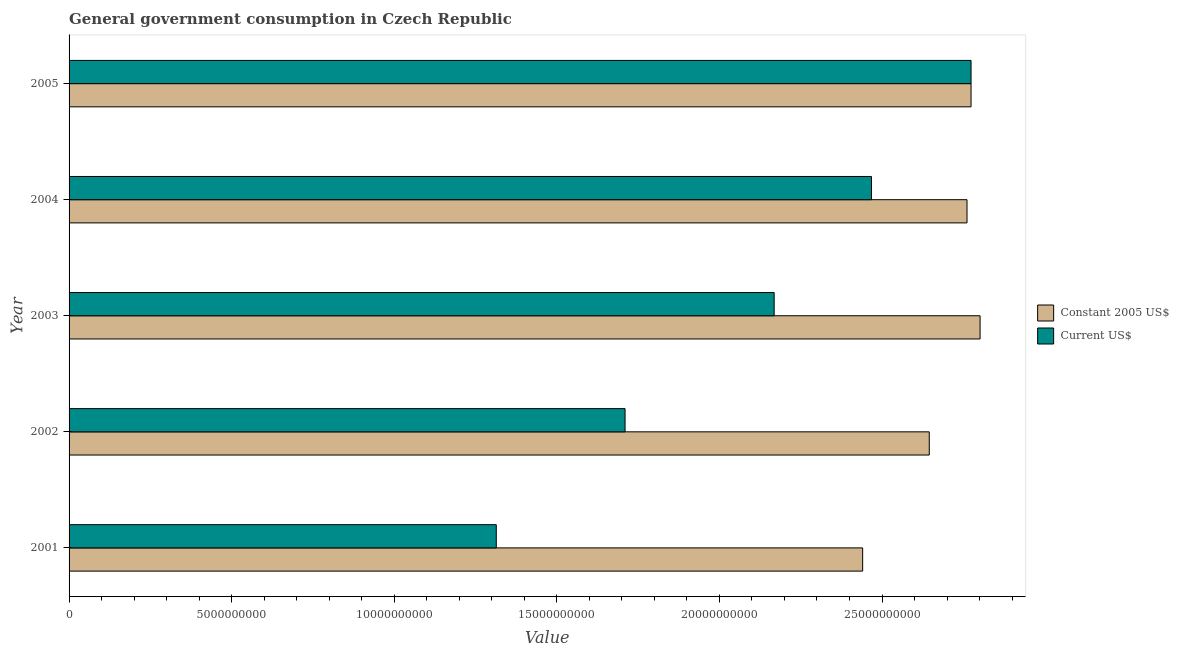How many bars are there on the 3rd tick from the bottom?
Keep it short and to the point. 2. What is the label of the 4th group of bars from the top?
Ensure brevity in your answer.  2002. What is the value consumed in constant 2005 us$ in 2002?
Give a very brief answer. 2.65e+1. Across all years, what is the maximum value consumed in constant 2005 us$?
Make the answer very short. 2.80e+1. Across all years, what is the minimum value consumed in current us$?
Your response must be concise. 1.31e+1. In which year was the value consumed in current us$ maximum?
Your answer should be very brief. 2005. What is the total value consumed in current us$ in the graph?
Offer a very short reply. 1.04e+11. What is the difference between the value consumed in current us$ in 2002 and that in 2003?
Make the answer very short. -4.59e+09. What is the difference between the value consumed in constant 2005 us$ in 2002 and the value consumed in current us$ in 2001?
Your response must be concise. 1.33e+1. What is the average value consumed in current us$ per year?
Offer a terse response. 2.09e+1. In the year 2001, what is the difference between the value consumed in current us$ and value consumed in constant 2005 us$?
Your response must be concise. -1.13e+1. What is the ratio of the value consumed in current us$ in 2001 to that in 2003?
Offer a terse response. 0.61. Is the difference between the value consumed in constant 2005 us$ in 2001 and 2002 greater than the difference between the value consumed in current us$ in 2001 and 2002?
Ensure brevity in your answer.  Yes. What is the difference between the highest and the second highest value consumed in current us$?
Your response must be concise. 3.06e+09. What is the difference between the highest and the lowest value consumed in constant 2005 us$?
Offer a very short reply. 3.61e+09. What does the 1st bar from the top in 2001 represents?
Provide a short and direct response. Current US$. What does the 1st bar from the bottom in 2004 represents?
Keep it short and to the point. Constant 2005 US$. How many bars are there?
Offer a very short reply. 10. Are all the bars in the graph horizontal?
Offer a very short reply. Yes. What is the difference between two consecutive major ticks on the X-axis?
Offer a very short reply. 5.00e+09. Where does the legend appear in the graph?
Give a very brief answer. Center right. How are the legend labels stacked?
Give a very brief answer. Vertical. What is the title of the graph?
Make the answer very short. General government consumption in Czech Republic. Does "Fixed telephone" appear as one of the legend labels in the graph?
Offer a very short reply. No. What is the label or title of the X-axis?
Give a very brief answer. Value. What is the label or title of the Y-axis?
Your answer should be compact. Year. What is the Value in Constant 2005 US$ in 2001?
Ensure brevity in your answer.  2.44e+1. What is the Value in Current US$ in 2001?
Ensure brevity in your answer.  1.31e+1. What is the Value of Constant 2005 US$ in 2002?
Provide a succinct answer. 2.65e+1. What is the Value of Current US$ in 2002?
Keep it short and to the point. 1.71e+1. What is the Value in Constant 2005 US$ in 2003?
Offer a very short reply. 2.80e+1. What is the Value of Current US$ in 2003?
Your answer should be very brief. 2.17e+1. What is the Value in Constant 2005 US$ in 2004?
Provide a short and direct response. 2.76e+1. What is the Value of Current US$ in 2004?
Provide a short and direct response. 2.47e+1. What is the Value of Constant 2005 US$ in 2005?
Your response must be concise. 2.77e+1. What is the Value of Current US$ in 2005?
Your answer should be very brief. 2.77e+1. Across all years, what is the maximum Value of Constant 2005 US$?
Offer a very short reply. 2.80e+1. Across all years, what is the maximum Value of Current US$?
Offer a terse response. 2.77e+1. Across all years, what is the minimum Value in Constant 2005 US$?
Your response must be concise. 2.44e+1. Across all years, what is the minimum Value of Current US$?
Ensure brevity in your answer.  1.31e+1. What is the total Value of Constant 2005 US$ in the graph?
Your answer should be compact. 1.34e+11. What is the total Value in Current US$ in the graph?
Your answer should be very brief. 1.04e+11. What is the difference between the Value of Constant 2005 US$ in 2001 and that in 2002?
Offer a terse response. -2.05e+09. What is the difference between the Value of Current US$ in 2001 and that in 2002?
Keep it short and to the point. -3.96e+09. What is the difference between the Value in Constant 2005 US$ in 2001 and that in 2003?
Offer a very short reply. -3.61e+09. What is the difference between the Value in Current US$ in 2001 and that in 2003?
Give a very brief answer. -8.55e+09. What is the difference between the Value in Constant 2005 US$ in 2001 and that in 2004?
Offer a terse response. -3.21e+09. What is the difference between the Value of Current US$ in 2001 and that in 2004?
Ensure brevity in your answer.  -1.15e+1. What is the difference between the Value in Constant 2005 US$ in 2001 and that in 2005?
Offer a terse response. -3.33e+09. What is the difference between the Value of Current US$ in 2001 and that in 2005?
Keep it short and to the point. -1.46e+1. What is the difference between the Value of Constant 2005 US$ in 2002 and that in 2003?
Your response must be concise. -1.56e+09. What is the difference between the Value in Current US$ in 2002 and that in 2003?
Offer a terse response. -4.59e+09. What is the difference between the Value of Constant 2005 US$ in 2002 and that in 2004?
Give a very brief answer. -1.16e+09. What is the difference between the Value of Current US$ in 2002 and that in 2004?
Give a very brief answer. -7.58e+09. What is the difference between the Value of Constant 2005 US$ in 2002 and that in 2005?
Your answer should be very brief. -1.28e+09. What is the difference between the Value in Current US$ in 2002 and that in 2005?
Provide a short and direct response. -1.06e+1. What is the difference between the Value of Constant 2005 US$ in 2003 and that in 2004?
Give a very brief answer. 4.02e+08. What is the difference between the Value of Current US$ in 2003 and that in 2004?
Your answer should be compact. -2.99e+09. What is the difference between the Value of Constant 2005 US$ in 2003 and that in 2005?
Offer a very short reply. 2.78e+08. What is the difference between the Value in Current US$ in 2003 and that in 2005?
Your answer should be very brief. -6.05e+09. What is the difference between the Value in Constant 2005 US$ in 2004 and that in 2005?
Ensure brevity in your answer.  -1.24e+08. What is the difference between the Value in Current US$ in 2004 and that in 2005?
Provide a short and direct response. -3.06e+09. What is the difference between the Value of Constant 2005 US$ in 2001 and the Value of Current US$ in 2002?
Ensure brevity in your answer.  7.31e+09. What is the difference between the Value of Constant 2005 US$ in 2001 and the Value of Current US$ in 2003?
Keep it short and to the point. 2.72e+09. What is the difference between the Value of Constant 2005 US$ in 2001 and the Value of Current US$ in 2004?
Give a very brief answer. -2.70e+08. What is the difference between the Value in Constant 2005 US$ in 2001 and the Value in Current US$ in 2005?
Provide a short and direct response. -3.33e+09. What is the difference between the Value in Constant 2005 US$ in 2002 and the Value in Current US$ in 2003?
Offer a terse response. 4.77e+09. What is the difference between the Value of Constant 2005 US$ in 2002 and the Value of Current US$ in 2004?
Provide a short and direct response. 1.78e+09. What is the difference between the Value in Constant 2005 US$ in 2002 and the Value in Current US$ in 2005?
Provide a succinct answer. -1.28e+09. What is the difference between the Value of Constant 2005 US$ in 2003 and the Value of Current US$ in 2004?
Keep it short and to the point. 3.34e+09. What is the difference between the Value of Constant 2005 US$ in 2003 and the Value of Current US$ in 2005?
Provide a succinct answer. 2.78e+08. What is the difference between the Value in Constant 2005 US$ in 2004 and the Value in Current US$ in 2005?
Your answer should be compact. -1.24e+08. What is the average Value of Constant 2005 US$ per year?
Offer a terse response. 2.68e+1. What is the average Value of Current US$ per year?
Provide a succinct answer. 2.09e+1. In the year 2001, what is the difference between the Value of Constant 2005 US$ and Value of Current US$?
Offer a very short reply. 1.13e+1. In the year 2002, what is the difference between the Value of Constant 2005 US$ and Value of Current US$?
Your answer should be very brief. 9.35e+09. In the year 2003, what is the difference between the Value in Constant 2005 US$ and Value in Current US$?
Your response must be concise. 6.33e+09. In the year 2004, what is the difference between the Value of Constant 2005 US$ and Value of Current US$?
Your response must be concise. 2.94e+09. In the year 2005, what is the difference between the Value of Constant 2005 US$ and Value of Current US$?
Provide a succinct answer. 0. What is the ratio of the Value in Constant 2005 US$ in 2001 to that in 2002?
Your answer should be very brief. 0.92. What is the ratio of the Value in Current US$ in 2001 to that in 2002?
Your response must be concise. 0.77. What is the ratio of the Value in Constant 2005 US$ in 2001 to that in 2003?
Provide a short and direct response. 0.87. What is the ratio of the Value of Current US$ in 2001 to that in 2003?
Give a very brief answer. 0.61. What is the ratio of the Value of Constant 2005 US$ in 2001 to that in 2004?
Keep it short and to the point. 0.88. What is the ratio of the Value of Current US$ in 2001 to that in 2004?
Your answer should be very brief. 0.53. What is the ratio of the Value of Constant 2005 US$ in 2001 to that in 2005?
Your answer should be compact. 0.88. What is the ratio of the Value in Current US$ in 2001 to that in 2005?
Ensure brevity in your answer.  0.47. What is the ratio of the Value of Constant 2005 US$ in 2002 to that in 2003?
Give a very brief answer. 0.94. What is the ratio of the Value in Current US$ in 2002 to that in 2003?
Give a very brief answer. 0.79. What is the ratio of the Value of Constant 2005 US$ in 2002 to that in 2004?
Give a very brief answer. 0.96. What is the ratio of the Value of Current US$ in 2002 to that in 2004?
Keep it short and to the point. 0.69. What is the ratio of the Value of Constant 2005 US$ in 2002 to that in 2005?
Offer a very short reply. 0.95. What is the ratio of the Value in Current US$ in 2002 to that in 2005?
Your answer should be very brief. 0.62. What is the ratio of the Value in Constant 2005 US$ in 2003 to that in 2004?
Ensure brevity in your answer.  1.01. What is the ratio of the Value in Current US$ in 2003 to that in 2004?
Your response must be concise. 0.88. What is the ratio of the Value in Current US$ in 2003 to that in 2005?
Make the answer very short. 0.78. What is the ratio of the Value in Constant 2005 US$ in 2004 to that in 2005?
Offer a very short reply. 1. What is the ratio of the Value in Current US$ in 2004 to that in 2005?
Provide a succinct answer. 0.89. What is the difference between the highest and the second highest Value of Constant 2005 US$?
Give a very brief answer. 2.78e+08. What is the difference between the highest and the second highest Value of Current US$?
Your answer should be very brief. 3.06e+09. What is the difference between the highest and the lowest Value of Constant 2005 US$?
Give a very brief answer. 3.61e+09. What is the difference between the highest and the lowest Value of Current US$?
Ensure brevity in your answer.  1.46e+1. 